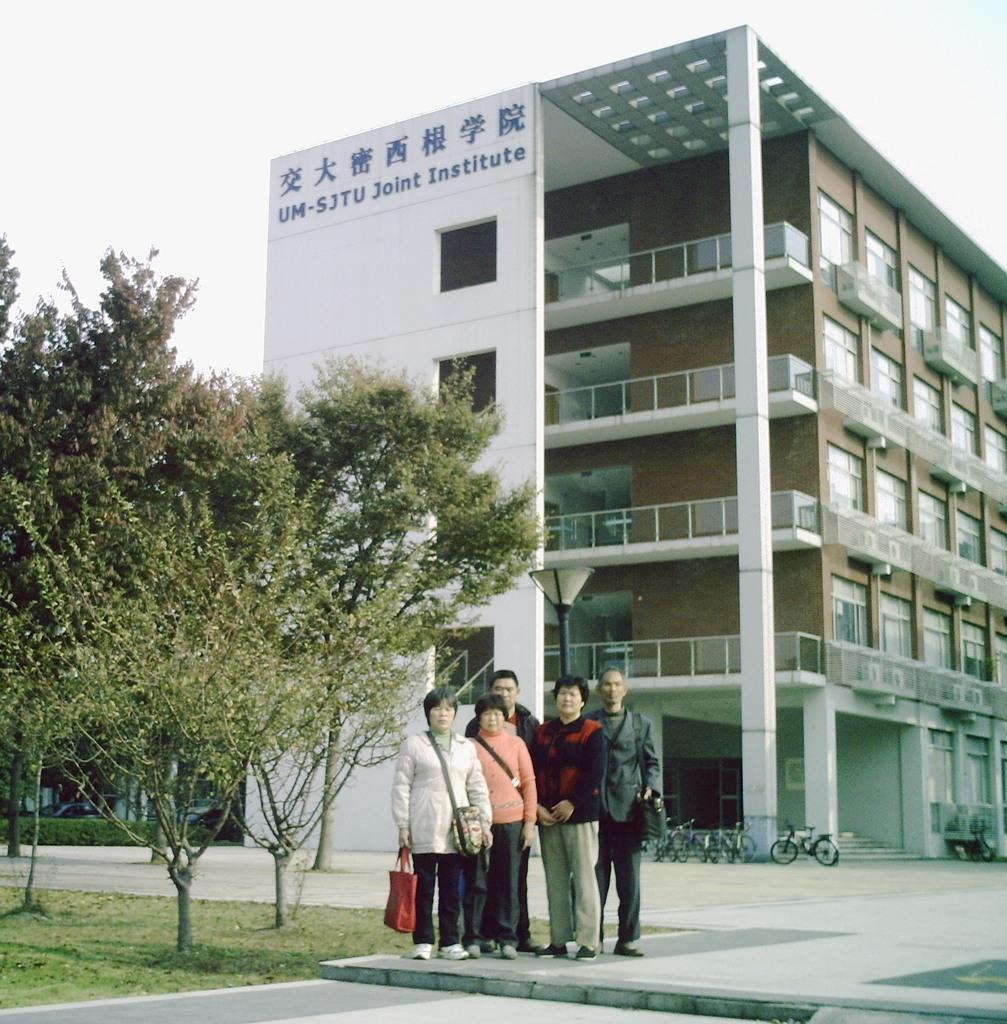Please provide a concise description of this image. In this image we can see these people are standing here, we can see trees, light poles, cycles parked here, building and the sky in the background. 